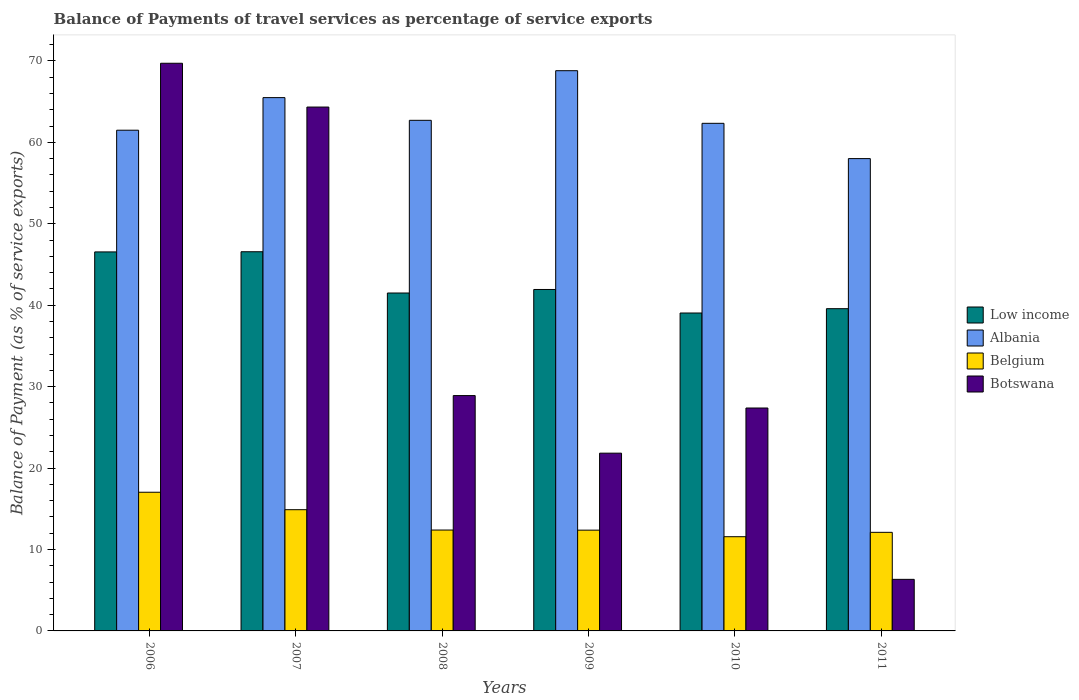Are the number of bars on each tick of the X-axis equal?
Ensure brevity in your answer.  Yes. What is the label of the 4th group of bars from the left?
Give a very brief answer. 2009. In how many cases, is the number of bars for a given year not equal to the number of legend labels?
Keep it short and to the point. 0. What is the balance of payments of travel services in Albania in 2006?
Ensure brevity in your answer.  61.49. Across all years, what is the maximum balance of payments of travel services in Botswana?
Provide a succinct answer. 69.71. Across all years, what is the minimum balance of payments of travel services in Low income?
Offer a very short reply. 39.04. In which year was the balance of payments of travel services in Low income maximum?
Ensure brevity in your answer.  2007. What is the total balance of payments of travel services in Low income in the graph?
Your answer should be very brief. 255.15. What is the difference between the balance of payments of travel services in Low income in 2009 and that in 2010?
Give a very brief answer. 2.89. What is the difference between the balance of payments of travel services in Botswana in 2007 and the balance of payments of travel services in Low income in 2009?
Provide a succinct answer. 22.4. What is the average balance of payments of travel services in Albania per year?
Your answer should be very brief. 63.14. In the year 2008, what is the difference between the balance of payments of travel services in Low income and balance of payments of travel services in Botswana?
Provide a succinct answer. 12.6. In how many years, is the balance of payments of travel services in Belgium greater than 18 %?
Your answer should be compact. 0. What is the ratio of the balance of payments of travel services in Low income in 2008 to that in 2009?
Make the answer very short. 0.99. Is the balance of payments of travel services in Belgium in 2008 less than that in 2010?
Offer a terse response. No. What is the difference between the highest and the second highest balance of payments of travel services in Albania?
Offer a terse response. 3.31. What is the difference between the highest and the lowest balance of payments of travel services in Belgium?
Provide a short and direct response. 5.46. What does the 4th bar from the left in 2007 represents?
Ensure brevity in your answer.  Botswana. What does the 1st bar from the right in 2010 represents?
Offer a terse response. Botswana. Is it the case that in every year, the sum of the balance of payments of travel services in Belgium and balance of payments of travel services in Albania is greater than the balance of payments of travel services in Low income?
Keep it short and to the point. Yes. How many bars are there?
Your response must be concise. 24. What is the difference between two consecutive major ticks on the Y-axis?
Provide a short and direct response. 10. Where does the legend appear in the graph?
Offer a terse response. Center right. How many legend labels are there?
Offer a very short reply. 4. What is the title of the graph?
Give a very brief answer. Balance of Payments of travel services as percentage of service exports. Does "Japan" appear as one of the legend labels in the graph?
Offer a terse response. No. What is the label or title of the Y-axis?
Your answer should be very brief. Balance of Payment (as % of service exports). What is the Balance of Payment (as % of service exports) in Low income in 2006?
Offer a terse response. 46.54. What is the Balance of Payment (as % of service exports) of Albania in 2006?
Provide a short and direct response. 61.49. What is the Balance of Payment (as % of service exports) of Belgium in 2006?
Your response must be concise. 17.03. What is the Balance of Payment (as % of service exports) of Botswana in 2006?
Provide a short and direct response. 69.71. What is the Balance of Payment (as % of service exports) in Low income in 2007?
Give a very brief answer. 46.56. What is the Balance of Payment (as % of service exports) of Albania in 2007?
Provide a succinct answer. 65.49. What is the Balance of Payment (as % of service exports) of Belgium in 2007?
Your response must be concise. 14.89. What is the Balance of Payment (as % of service exports) of Botswana in 2007?
Give a very brief answer. 64.33. What is the Balance of Payment (as % of service exports) of Low income in 2008?
Make the answer very short. 41.5. What is the Balance of Payment (as % of service exports) in Albania in 2008?
Your answer should be compact. 62.7. What is the Balance of Payment (as % of service exports) of Belgium in 2008?
Your answer should be compact. 12.39. What is the Balance of Payment (as % of service exports) in Botswana in 2008?
Offer a very short reply. 28.9. What is the Balance of Payment (as % of service exports) in Low income in 2009?
Give a very brief answer. 41.93. What is the Balance of Payment (as % of service exports) of Albania in 2009?
Offer a terse response. 68.8. What is the Balance of Payment (as % of service exports) of Belgium in 2009?
Ensure brevity in your answer.  12.37. What is the Balance of Payment (as % of service exports) of Botswana in 2009?
Provide a succinct answer. 21.83. What is the Balance of Payment (as % of service exports) in Low income in 2010?
Keep it short and to the point. 39.04. What is the Balance of Payment (as % of service exports) in Albania in 2010?
Your response must be concise. 62.34. What is the Balance of Payment (as % of service exports) in Belgium in 2010?
Your answer should be very brief. 11.57. What is the Balance of Payment (as % of service exports) in Botswana in 2010?
Keep it short and to the point. 27.38. What is the Balance of Payment (as % of service exports) in Low income in 2011?
Ensure brevity in your answer.  39.57. What is the Balance of Payment (as % of service exports) of Albania in 2011?
Make the answer very short. 58. What is the Balance of Payment (as % of service exports) of Belgium in 2011?
Your answer should be very brief. 12.11. What is the Balance of Payment (as % of service exports) in Botswana in 2011?
Your response must be concise. 6.33. Across all years, what is the maximum Balance of Payment (as % of service exports) in Low income?
Ensure brevity in your answer.  46.56. Across all years, what is the maximum Balance of Payment (as % of service exports) of Albania?
Your response must be concise. 68.8. Across all years, what is the maximum Balance of Payment (as % of service exports) in Belgium?
Your response must be concise. 17.03. Across all years, what is the maximum Balance of Payment (as % of service exports) in Botswana?
Provide a short and direct response. 69.71. Across all years, what is the minimum Balance of Payment (as % of service exports) of Low income?
Your response must be concise. 39.04. Across all years, what is the minimum Balance of Payment (as % of service exports) of Albania?
Your response must be concise. 58. Across all years, what is the minimum Balance of Payment (as % of service exports) of Belgium?
Provide a succinct answer. 11.57. Across all years, what is the minimum Balance of Payment (as % of service exports) in Botswana?
Provide a short and direct response. 6.33. What is the total Balance of Payment (as % of service exports) in Low income in the graph?
Give a very brief answer. 255.15. What is the total Balance of Payment (as % of service exports) of Albania in the graph?
Offer a terse response. 378.83. What is the total Balance of Payment (as % of service exports) in Belgium in the graph?
Ensure brevity in your answer.  80.36. What is the total Balance of Payment (as % of service exports) in Botswana in the graph?
Ensure brevity in your answer.  218.49. What is the difference between the Balance of Payment (as % of service exports) of Low income in 2006 and that in 2007?
Offer a very short reply. -0.02. What is the difference between the Balance of Payment (as % of service exports) of Albania in 2006 and that in 2007?
Your answer should be compact. -4. What is the difference between the Balance of Payment (as % of service exports) of Belgium in 2006 and that in 2007?
Your answer should be very brief. 2.14. What is the difference between the Balance of Payment (as % of service exports) of Botswana in 2006 and that in 2007?
Your response must be concise. 5.38. What is the difference between the Balance of Payment (as % of service exports) of Low income in 2006 and that in 2008?
Provide a short and direct response. 5.05. What is the difference between the Balance of Payment (as % of service exports) in Albania in 2006 and that in 2008?
Provide a succinct answer. -1.21. What is the difference between the Balance of Payment (as % of service exports) of Belgium in 2006 and that in 2008?
Provide a short and direct response. 4.64. What is the difference between the Balance of Payment (as % of service exports) of Botswana in 2006 and that in 2008?
Provide a succinct answer. 40.81. What is the difference between the Balance of Payment (as % of service exports) of Low income in 2006 and that in 2009?
Offer a very short reply. 4.61. What is the difference between the Balance of Payment (as % of service exports) of Albania in 2006 and that in 2009?
Offer a very short reply. -7.31. What is the difference between the Balance of Payment (as % of service exports) in Belgium in 2006 and that in 2009?
Offer a very short reply. 4.66. What is the difference between the Balance of Payment (as % of service exports) of Botswana in 2006 and that in 2009?
Your answer should be compact. 47.88. What is the difference between the Balance of Payment (as % of service exports) in Low income in 2006 and that in 2010?
Give a very brief answer. 7.5. What is the difference between the Balance of Payment (as % of service exports) of Albania in 2006 and that in 2010?
Keep it short and to the point. -0.85. What is the difference between the Balance of Payment (as % of service exports) of Belgium in 2006 and that in 2010?
Keep it short and to the point. 5.46. What is the difference between the Balance of Payment (as % of service exports) of Botswana in 2006 and that in 2010?
Your answer should be very brief. 42.34. What is the difference between the Balance of Payment (as % of service exports) in Low income in 2006 and that in 2011?
Offer a very short reply. 6.97. What is the difference between the Balance of Payment (as % of service exports) in Albania in 2006 and that in 2011?
Keep it short and to the point. 3.49. What is the difference between the Balance of Payment (as % of service exports) in Belgium in 2006 and that in 2011?
Provide a short and direct response. 4.92. What is the difference between the Balance of Payment (as % of service exports) of Botswana in 2006 and that in 2011?
Ensure brevity in your answer.  63.38. What is the difference between the Balance of Payment (as % of service exports) in Low income in 2007 and that in 2008?
Your response must be concise. 5.07. What is the difference between the Balance of Payment (as % of service exports) in Albania in 2007 and that in 2008?
Make the answer very short. 2.79. What is the difference between the Balance of Payment (as % of service exports) in Belgium in 2007 and that in 2008?
Offer a very short reply. 2.5. What is the difference between the Balance of Payment (as % of service exports) of Botswana in 2007 and that in 2008?
Provide a short and direct response. 35.43. What is the difference between the Balance of Payment (as % of service exports) in Low income in 2007 and that in 2009?
Offer a very short reply. 4.63. What is the difference between the Balance of Payment (as % of service exports) in Albania in 2007 and that in 2009?
Offer a very short reply. -3.31. What is the difference between the Balance of Payment (as % of service exports) in Belgium in 2007 and that in 2009?
Provide a short and direct response. 2.51. What is the difference between the Balance of Payment (as % of service exports) of Botswana in 2007 and that in 2009?
Your answer should be compact. 42.5. What is the difference between the Balance of Payment (as % of service exports) of Low income in 2007 and that in 2010?
Your answer should be compact. 7.52. What is the difference between the Balance of Payment (as % of service exports) of Albania in 2007 and that in 2010?
Keep it short and to the point. 3.16. What is the difference between the Balance of Payment (as % of service exports) of Belgium in 2007 and that in 2010?
Ensure brevity in your answer.  3.32. What is the difference between the Balance of Payment (as % of service exports) of Botswana in 2007 and that in 2010?
Your response must be concise. 36.96. What is the difference between the Balance of Payment (as % of service exports) of Low income in 2007 and that in 2011?
Keep it short and to the point. 6.99. What is the difference between the Balance of Payment (as % of service exports) in Albania in 2007 and that in 2011?
Your answer should be very brief. 7.49. What is the difference between the Balance of Payment (as % of service exports) in Belgium in 2007 and that in 2011?
Ensure brevity in your answer.  2.78. What is the difference between the Balance of Payment (as % of service exports) in Botswana in 2007 and that in 2011?
Give a very brief answer. 58. What is the difference between the Balance of Payment (as % of service exports) in Low income in 2008 and that in 2009?
Make the answer very short. -0.43. What is the difference between the Balance of Payment (as % of service exports) of Albania in 2008 and that in 2009?
Keep it short and to the point. -6.09. What is the difference between the Balance of Payment (as % of service exports) of Belgium in 2008 and that in 2009?
Provide a succinct answer. 0.01. What is the difference between the Balance of Payment (as % of service exports) in Botswana in 2008 and that in 2009?
Offer a very short reply. 7.07. What is the difference between the Balance of Payment (as % of service exports) in Low income in 2008 and that in 2010?
Keep it short and to the point. 2.46. What is the difference between the Balance of Payment (as % of service exports) in Albania in 2008 and that in 2010?
Keep it short and to the point. 0.37. What is the difference between the Balance of Payment (as % of service exports) of Belgium in 2008 and that in 2010?
Ensure brevity in your answer.  0.82. What is the difference between the Balance of Payment (as % of service exports) in Botswana in 2008 and that in 2010?
Give a very brief answer. 1.53. What is the difference between the Balance of Payment (as % of service exports) in Low income in 2008 and that in 2011?
Provide a short and direct response. 1.92. What is the difference between the Balance of Payment (as % of service exports) in Albania in 2008 and that in 2011?
Offer a terse response. 4.7. What is the difference between the Balance of Payment (as % of service exports) of Belgium in 2008 and that in 2011?
Offer a very short reply. 0.28. What is the difference between the Balance of Payment (as % of service exports) of Botswana in 2008 and that in 2011?
Your answer should be very brief. 22.57. What is the difference between the Balance of Payment (as % of service exports) of Low income in 2009 and that in 2010?
Provide a succinct answer. 2.89. What is the difference between the Balance of Payment (as % of service exports) of Albania in 2009 and that in 2010?
Offer a terse response. 6.46. What is the difference between the Balance of Payment (as % of service exports) of Belgium in 2009 and that in 2010?
Offer a very short reply. 0.81. What is the difference between the Balance of Payment (as % of service exports) in Botswana in 2009 and that in 2010?
Your answer should be very brief. -5.55. What is the difference between the Balance of Payment (as % of service exports) in Low income in 2009 and that in 2011?
Your answer should be very brief. 2.36. What is the difference between the Balance of Payment (as % of service exports) of Albania in 2009 and that in 2011?
Your answer should be compact. 10.79. What is the difference between the Balance of Payment (as % of service exports) of Belgium in 2009 and that in 2011?
Give a very brief answer. 0.27. What is the difference between the Balance of Payment (as % of service exports) in Botswana in 2009 and that in 2011?
Your answer should be compact. 15.5. What is the difference between the Balance of Payment (as % of service exports) of Low income in 2010 and that in 2011?
Provide a short and direct response. -0.53. What is the difference between the Balance of Payment (as % of service exports) in Albania in 2010 and that in 2011?
Provide a short and direct response. 4.33. What is the difference between the Balance of Payment (as % of service exports) of Belgium in 2010 and that in 2011?
Offer a very short reply. -0.54. What is the difference between the Balance of Payment (as % of service exports) of Botswana in 2010 and that in 2011?
Make the answer very short. 21.04. What is the difference between the Balance of Payment (as % of service exports) in Low income in 2006 and the Balance of Payment (as % of service exports) in Albania in 2007?
Your answer should be compact. -18.95. What is the difference between the Balance of Payment (as % of service exports) of Low income in 2006 and the Balance of Payment (as % of service exports) of Belgium in 2007?
Offer a terse response. 31.66. What is the difference between the Balance of Payment (as % of service exports) in Low income in 2006 and the Balance of Payment (as % of service exports) in Botswana in 2007?
Give a very brief answer. -17.79. What is the difference between the Balance of Payment (as % of service exports) in Albania in 2006 and the Balance of Payment (as % of service exports) in Belgium in 2007?
Make the answer very short. 46.6. What is the difference between the Balance of Payment (as % of service exports) in Albania in 2006 and the Balance of Payment (as % of service exports) in Botswana in 2007?
Keep it short and to the point. -2.84. What is the difference between the Balance of Payment (as % of service exports) of Belgium in 2006 and the Balance of Payment (as % of service exports) of Botswana in 2007?
Your response must be concise. -47.3. What is the difference between the Balance of Payment (as % of service exports) of Low income in 2006 and the Balance of Payment (as % of service exports) of Albania in 2008?
Your answer should be very brief. -16.16. What is the difference between the Balance of Payment (as % of service exports) in Low income in 2006 and the Balance of Payment (as % of service exports) in Belgium in 2008?
Your response must be concise. 34.16. What is the difference between the Balance of Payment (as % of service exports) in Low income in 2006 and the Balance of Payment (as % of service exports) in Botswana in 2008?
Offer a terse response. 17.64. What is the difference between the Balance of Payment (as % of service exports) in Albania in 2006 and the Balance of Payment (as % of service exports) in Belgium in 2008?
Ensure brevity in your answer.  49.1. What is the difference between the Balance of Payment (as % of service exports) in Albania in 2006 and the Balance of Payment (as % of service exports) in Botswana in 2008?
Your answer should be very brief. 32.59. What is the difference between the Balance of Payment (as % of service exports) in Belgium in 2006 and the Balance of Payment (as % of service exports) in Botswana in 2008?
Offer a terse response. -11.87. What is the difference between the Balance of Payment (as % of service exports) in Low income in 2006 and the Balance of Payment (as % of service exports) in Albania in 2009?
Offer a terse response. -22.25. What is the difference between the Balance of Payment (as % of service exports) in Low income in 2006 and the Balance of Payment (as % of service exports) in Belgium in 2009?
Provide a succinct answer. 34.17. What is the difference between the Balance of Payment (as % of service exports) of Low income in 2006 and the Balance of Payment (as % of service exports) of Botswana in 2009?
Ensure brevity in your answer.  24.72. What is the difference between the Balance of Payment (as % of service exports) in Albania in 2006 and the Balance of Payment (as % of service exports) in Belgium in 2009?
Ensure brevity in your answer.  49.12. What is the difference between the Balance of Payment (as % of service exports) in Albania in 2006 and the Balance of Payment (as % of service exports) in Botswana in 2009?
Keep it short and to the point. 39.66. What is the difference between the Balance of Payment (as % of service exports) in Belgium in 2006 and the Balance of Payment (as % of service exports) in Botswana in 2009?
Provide a succinct answer. -4.8. What is the difference between the Balance of Payment (as % of service exports) of Low income in 2006 and the Balance of Payment (as % of service exports) of Albania in 2010?
Your answer should be very brief. -15.79. What is the difference between the Balance of Payment (as % of service exports) of Low income in 2006 and the Balance of Payment (as % of service exports) of Belgium in 2010?
Ensure brevity in your answer.  34.98. What is the difference between the Balance of Payment (as % of service exports) of Low income in 2006 and the Balance of Payment (as % of service exports) of Botswana in 2010?
Provide a succinct answer. 19.17. What is the difference between the Balance of Payment (as % of service exports) of Albania in 2006 and the Balance of Payment (as % of service exports) of Belgium in 2010?
Your answer should be compact. 49.92. What is the difference between the Balance of Payment (as % of service exports) in Albania in 2006 and the Balance of Payment (as % of service exports) in Botswana in 2010?
Offer a terse response. 34.12. What is the difference between the Balance of Payment (as % of service exports) in Belgium in 2006 and the Balance of Payment (as % of service exports) in Botswana in 2010?
Keep it short and to the point. -10.34. What is the difference between the Balance of Payment (as % of service exports) in Low income in 2006 and the Balance of Payment (as % of service exports) in Albania in 2011?
Offer a terse response. -11.46. What is the difference between the Balance of Payment (as % of service exports) in Low income in 2006 and the Balance of Payment (as % of service exports) in Belgium in 2011?
Give a very brief answer. 34.44. What is the difference between the Balance of Payment (as % of service exports) of Low income in 2006 and the Balance of Payment (as % of service exports) of Botswana in 2011?
Your answer should be very brief. 40.21. What is the difference between the Balance of Payment (as % of service exports) in Albania in 2006 and the Balance of Payment (as % of service exports) in Belgium in 2011?
Ensure brevity in your answer.  49.38. What is the difference between the Balance of Payment (as % of service exports) in Albania in 2006 and the Balance of Payment (as % of service exports) in Botswana in 2011?
Keep it short and to the point. 55.16. What is the difference between the Balance of Payment (as % of service exports) in Belgium in 2006 and the Balance of Payment (as % of service exports) in Botswana in 2011?
Offer a very short reply. 10.7. What is the difference between the Balance of Payment (as % of service exports) in Low income in 2007 and the Balance of Payment (as % of service exports) in Albania in 2008?
Offer a terse response. -16.14. What is the difference between the Balance of Payment (as % of service exports) in Low income in 2007 and the Balance of Payment (as % of service exports) in Belgium in 2008?
Offer a terse response. 34.18. What is the difference between the Balance of Payment (as % of service exports) in Low income in 2007 and the Balance of Payment (as % of service exports) in Botswana in 2008?
Your response must be concise. 17.66. What is the difference between the Balance of Payment (as % of service exports) in Albania in 2007 and the Balance of Payment (as % of service exports) in Belgium in 2008?
Offer a very short reply. 53.1. What is the difference between the Balance of Payment (as % of service exports) in Albania in 2007 and the Balance of Payment (as % of service exports) in Botswana in 2008?
Make the answer very short. 36.59. What is the difference between the Balance of Payment (as % of service exports) in Belgium in 2007 and the Balance of Payment (as % of service exports) in Botswana in 2008?
Offer a terse response. -14.01. What is the difference between the Balance of Payment (as % of service exports) of Low income in 2007 and the Balance of Payment (as % of service exports) of Albania in 2009?
Your response must be concise. -22.23. What is the difference between the Balance of Payment (as % of service exports) in Low income in 2007 and the Balance of Payment (as % of service exports) in Belgium in 2009?
Give a very brief answer. 34.19. What is the difference between the Balance of Payment (as % of service exports) in Low income in 2007 and the Balance of Payment (as % of service exports) in Botswana in 2009?
Make the answer very short. 24.74. What is the difference between the Balance of Payment (as % of service exports) in Albania in 2007 and the Balance of Payment (as % of service exports) in Belgium in 2009?
Make the answer very short. 53.12. What is the difference between the Balance of Payment (as % of service exports) in Albania in 2007 and the Balance of Payment (as % of service exports) in Botswana in 2009?
Ensure brevity in your answer.  43.66. What is the difference between the Balance of Payment (as % of service exports) of Belgium in 2007 and the Balance of Payment (as % of service exports) of Botswana in 2009?
Provide a short and direct response. -6.94. What is the difference between the Balance of Payment (as % of service exports) in Low income in 2007 and the Balance of Payment (as % of service exports) in Albania in 2010?
Make the answer very short. -15.77. What is the difference between the Balance of Payment (as % of service exports) of Low income in 2007 and the Balance of Payment (as % of service exports) of Belgium in 2010?
Ensure brevity in your answer.  35. What is the difference between the Balance of Payment (as % of service exports) of Low income in 2007 and the Balance of Payment (as % of service exports) of Botswana in 2010?
Your response must be concise. 19.19. What is the difference between the Balance of Payment (as % of service exports) in Albania in 2007 and the Balance of Payment (as % of service exports) in Belgium in 2010?
Keep it short and to the point. 53.92. What is the difference between the Balance of Payment (as % of service exports) in Albania in 2007 and the Balance of Payment (as % of service exports) in Botswana in 2010?
Make the answer very short. 38.12. What is the difference between the Balance of Payment (as % of service exports) of Belgium in 2007 and the Balance of Payment (as % of service exports) of Botswana in 2010?
Your response must be concise. -12.49. What is the difference between the Balance of Payment (as % of service exports) in Low income in 2007 and the Balance of Payment (as % of service exports) in Albania in 2011?
Ensure brevity in your answer.  -11.44. What is the difference between the Balance of Payment (as % of service exports) of Low income in 2007 and the Balance of Payment (as % of service exports) of Belgium in 2011?
Offer a terse response. 34.46. What is the difference between the Balance of Payment (as % of service exports) in Low income in 2007 and the Balance of Payment (as % of service exports) in Botswana in 2011?
Offer a very short reply. 40.23. What is the difference between the Balance of Payment (as % of service exports) in Albania in 2007 and the Balance of Payment (as % of service exports) in Belgium in 2011?
Offer a very short reply. 53.39. What is the difference between the Balance of Payment (as % of service exports) of Albania in 2007 and the Balance of Payment (as % of service exports) of Botswana in 2011?
Keep it short and to the point. 59.16. What is the difference between the Balance of Payment (as % of service exports) in Belgium in 2007 and the Balance of Payment (as % of service exports) in Botswana in 2011?
Offer a terse response. 8.55. What is the difference between the Balance of Payment (as % of service exports) in Low income in 2008 and the Balance of Payment (as % of service exports) in Albania in 2009?
Your answer should be compact. -27.3. What is the difference between the Balance of Payment (as % of service exports) of Low income in 2008 and the Balance of Payment (as % of service exports) of Belgium in 2009?
Keep it short and to the point. 29.12. What is the difference between the Balance of Payment (as % of service exports) in Low income in 2008 and the Balance of Payment (as % of service exports) in Botswana in 2009?
Provide a short and direct response. 19.67. What is the difference between the Balance of Payment (as % of service exports) of Albania in 2008 and the Balance of Payment (as % of service exports) of Belgium in 2009?
Keep it short and to the point. 50.33. What is the difference between the Balance of Payment (as % of service exports) in Albania in 2008 and the Balance of Payment (as % of service exports) in Botswana in 2009?
Offer a very short reply. 40.88. What is the difference between the Balance of Payment (as % of service exports) of Belgium in 2008 and the Balance of Payment (as % of service exports) of Botswana in 2009?
Ensure brevity in your answer.  -9.44. What is the difference between the Balance of Payment (as % of service exports) in Low income in 2008 and the Balance of Payment (as % of service exports) in Albania in 2010?
Provide a succinct answer. -20.84. What is the difference between the Balance of Payment (as % of service exports) of Low income in 2008 and the Balance of Payment (as % of service exports) of Belgium in 2010?
Offer a very short reply. 29.93. What is the difference between the Balance of Payment (as % of service exports) in Low income in 2008 and the Balance of Payment (as % of service exports) in Botswana in 2010?
Provide a succinct answer. 14.12. What is the difference between the Balance of Payment (as % of service exports) in Albania in 2008 and the Balance of Payment (as % of service exports) in Belgium in 2010?
Your answer should be very brief. 51.14. What is the difference between the Balance of Payment (as % of service exports) of Albania in 2008 and the Balance of Payment (as % of service exports) of Botswana in 2010?
Offer a terse response. 35.33. What is the difference between the Balance of Payment (as % of service exports) in Belgium in 2008 and the Balance of Payment (as % of service exports) in Botswana in 2010?
Keep it short and to the point. -14.99. What is the difference between the Balance of Payment (as % of service exports) of Low income in 2008 and the Balance of Payment (as % of service exports) of Albania in 2011?
Give a very brief answer. -16.51. What is the difference between the Balance of Payment (as % of service exports) of Low income in 2008 and the Balance of Payment (as % of service exports) of Belgium in 2011?
Ensure brevity in your answer.  29.39. What is the difference between the Balance of Payment (as % of service exports) in Low income in 2008 and the Balance of Payment (as % of service exports) in Botswana in 2011?
Keep it short and to the point. 35.16. What is the difference between the Balance of Payment (as % of service exports) of Albania in 2008 and the Balance of Payment (as % of service exports) of Belgium in 2011?
Give a very brief answer. 50.6. What is the difference between the Balance of Payment (as % of service exports) in Albania in 2008 and the Balance of Payment (as % of service exports) in Botswana in 2011?
Give a very brief answer. 56.37. What is the difference between the Balance of Payment (as % of service exports) of Belgium in 2008 and the Balance of Payment (as % of service exports) of Botswana in 2011?
Ensure brevity in your answer.  6.06. What is the difference between the Balance of Payment (as % of service exports) in Low income in 2009 and the Balance of Payment (as % of service exports) in Albania in 2010?
Provide a short and direct response. -20.41. What is the difference between the Balance of Payment (as % of service exports) in Low income in 2009 and the Balance of Payment (as % of service exports) in Belgium in 2010?
Make the answer very short. 30.36. What is the difference between the Balance of Payment (as % of service exports) of Low income in 2009 and the Balance of Payment (as % of service exports) of Botswana in 2010?
Ensure brevity in your answer.  14.56. What is the difference between the Balance of Payment (as % of service exports) of Albania in 2009 and the Balance of Payment (as % of service exports) of Belgium in 2010?
Give a very brief answer. 57.23. What is the difference between the Balance of Payment (as % of service exports) in Albania in 2009 and the Balance of Payment (as % of service exports) in Botswana in 2010?
Give a very brief answer. 41.42. What is the difference between the Balance of Payment (as % of service exports) of Belgium in 2009 and the Balance of Payment (as % of service exports) of Botswana in 2010?
Provide a short and direct response. -15. What is the difference between the Balance of Payment (as % of service exports) of Low income in 2009 and the Balance of Payment (as % of service exports) of Albania in 2011?
Make the answer very short. -16.07. What is the difference between the Balance of Payment (as % of service exports) of Low income in 2009 and the Balance of Payment (as % of service exports) of Belgium in 2011?
Offer a very short reply. 29.82. What is the difference between the Balance of Payment (as % of service exports) in Low income in 2009 and the Balance of Payment (as % of service exports) in Botswana in 2011?
Your response must be concise. 35.6. What is the difference between the Balance of Payment (as % of service exports) of Albania in 2009 and the Balance of Payment (as % of service exports) of Belgium in 2011?
Make the answer very short. 56.69. What is the difference between the Balance of Payment (as % of service exports) of Albania in 2009 and the Balance of Payment (as % of service exports) of Botswana in 2011?
Ensure brevity in your answer.  62.46. What is the difference between the Balance of Payment (as % of service exports) in Belgium in 2009 and the Balance of Payment (as % of service exports) in Botswana in 2011?
Your response must be concise. 6.04. What is the difference between the Balance of Payment (as % of service exports) of Low income in 2010 and the Balance of Payment (as % of service exports) of Albania in 2011?
Ensure brevity in your answer.  -18.96. What is the difference between the Balance of Payment (as % of service exports) of Low income in 2010 and the Balance of Payment (as % of service exports) of Belgium in 2011?
Give a very brief answer. 26.93. What is the difference between the Balance of Payment (as % of service exports) of Low income in 2010 and the Balance of Payment (as % of service exports) of Botswana in 2011?
Provide a short and direct response. 32.71. What is the difference between the Balance of Payment (as % of service exports) in Albania in 2010 and the Balance of Payment (as % of service exports) in Belgium in 2011?
Your answer should be very brief. 50.23. What is the difference between the Balance of Payment (as % of service exports) in Albania in 2010 and the Balance of Payment (as % of service exports) in Botswana in 2011?
Provide a short and direct response. 56. What is the difference between the Balance of Payment (as % of service exports) of Belgium in 2010 and the Balance of Payment (as % of service exports) of Botswana in 2011?
Your answer should be very brief. 5.24. What is the average Balance of Payment (as % of service exports) in Low income per year?
Your answer should be compact. 42.53. What is the average Balance of Payment (as % of service exports) in Albania per year?
Ensure brevity in your answer.  63.14. What is the average Balance of Payment (as % of service exports) of Belgium per year?
Give a very brief answer. 13.39. What is the average Balance of Payment (as % of service exports) in Botswana per year?
Provide a short and direct response. 36.41. In the year 2006, what is the difference between the Balance of Payment (as % of service exports) of Low income and Balance of Payment (as % of service exports) of Albania?
Your answer should be compact. -14.95. In the year 2006, what is the difference between the Balance of Payment (as % of service exports) of Low income and Balance of Payment (as % of service exports) of Belgium?
Provide a short and direct response. 29.51. In the year 2006, what is the difference between the Balance of Payment (as % of service exports) of Low income and Balance of Payment (as % of service exports) of Botswana?
Make the answer very short. -23.17. In the year 2006, what is the difference between the Balance of Payment (as % of service exports) in Albania and Balance of Payment (as % of service exports) in Belgium?
Provide a succinct answer. 44.46. In the year 2006, what is the difference between the Balance of Payment (as % of service exports) in Albania and Balance of Payment (as % of service exports) in Botswana?
Offer a terse response. -8.22. In the year 2006, what is the difference between the Balance of Payment (as % of service exports) of Belgium and Balance of Payment (as % of service exports) of Botswana?
Your answer should be very brief. -52.68. In the year 2007, what is the difference between the Balance of Payment (as % of service exports) of Low income and Balance of Payment (as % of service exports) of Albania?
Provide a short and direct response. -18.93. In the year 2007, what is the difference between the Balance of Payment (as % of service exports) in Low income and Balance of Payment (as % of service exports) in Belgium?
Ensure brevity in your answer.  31.68. In the year 2007, what is the difference between the Balance of Payment (as % of service exports) in Low income and Balance of Payment (as % of service exports) in Botswana?
Make the answer very short. -17.77. In the year 2007, what is the difference between the Balance of Payment (as % of service exports) of Albania and Balance of Payment (as % of service exports) of Belgium?
Make the answer very short. 50.6. In the year 2007, what is the difference between the Balance of Payment (as % of service exports) in Albania and Balance of Payment (as % of service exports) in Botswana?
Give a very brief answer. 1.16. In the year 2007, what is the difference between the Balance of Payment (as % of service exports) of Belgium and Balance of Payment (as % of service exports) of Botswana?
Keep it short and to the point. -49.45. In the year 2008, what is the difference between the Balance of Payment (as % of service exports) of Low income and Balance of Payment (as % of service exports) of Albania?
Make the answer very short. -21.21. In the year 2008, what is the difference between the Balance of Payment (as % of service exports) in Low income and Balance of Payment (as % of service exports) in Belgium?
Give a very brief answer. 29.11. In the year 2008, what is the difference between the Balance of Payment (as % of service exports) of Low income and Balance of Payment (as % of service exports) of Botswana?
Make the answer very short. 12.6. In the year 2008, what is the difference between the Balance of Payment (as % of service exports) of Albania and Balance of Payment (as % of service exports) of Belgium?
Your answer should be compact. 50.32. In the year 2008, what is the difference between the Balance of Payment (as % of service exports) in Albania and Balance of Payment (as % of service exports) in Botswana?
Provide a succinct answer. 33.8. In the year 2008, what is the difference between the Balance of Payment (as % of service exports) in Belgium and Balance of Payment (as % of service exports) in Botswana?
Your response must be concise. -16.51. In the year 2009, what is the difference between the Balance of Payment (as % of service exports) of Low income and Balance of Payment (as % of service exports) of Albania?
Ensure brevity in your answer.  -26.87. In the year 2009, what is the difference between the Balance of Payment (as % of service exports) of Low income and Balance of Payment (as % of service exports) of Belgium?
Provide a short and direct response. 29.56. In the year 2009, what is the difference between the Balance of Payment (as % of service exports) of Low income and Balance of Payment (as % of service exports) of Botswana?
Give a very brief answer. 20.1. In the year 2009, what is the difference between the Balance of Payment (as % of service exports) in Albania and Balance of Payment (as % of service exports) in Belgium?
Make the answer very short. 56.42. In the year 2009, what is the difference between the Balance of Payment (as % of service exports) of Albania and Balance of Payment (as % of service exports) of Botswana?
Make the answer very short. 46.97. In the year 2009, what is the difference between the Balance of Payment (as % of service exports) in Belgium and Balance of Payment (as % of service exports) in Botswana?
Your answer should be very brief. -9.45. In the year 2010, what is the difference between the Balance of Payment (as % of service exports) in Low income and Balance of Payment (as % of service exports) in Albania?
Your answer should be very brief. -23.3. In the year 2010, what is the difference between the Balance of Payment (as % of service exports) in Low income and Balance of Payment (as % of service exports) in Belgium?
Provide a succinct answer. 27.47. In the year 2010, what is the difference between the Balance of Payment (as % of service exports) in Low income and Balance of Payment (as % of service exports) in Botswana?
Make the answer very short. 11.67. In the year 2010, what is the difference between the Balance of Payment (as % of service exports) in Albania and Balance of Payment (as % of service exports) in Belgium?
Provide a short and direct response. 50.77. In the year 2010, what is the difference between the Balance of Payment (as % of service exports) of Albania and Balance of Payment (as % of service exports) of Botswana?
Provide a short and direct response. 34.96. In the year 2010, what is the difference between the Balance of Payment (as % of service exports) of Belgium and Balance of Payment (as % of service exports) of Botswana?
Provide a short and direct response. -15.81. In the year 2011, what is the difference between the Balance of Payment (as % of service exports) in Low income and Balance of Payment (as % of service exports) in Albania?
Provide a short and direct response. -18.43. In the year 2011, what is the difference between the Balance of Payment (as % of service exports) in Low income and Balance of Payment (as % of service exports) in Belgium?
Your response must be concise. 27.47. In the year 2011, what is the difference between the Balance of Payment (as % of service exports) of Low income and Balance of Payment (as % of service exports) of Botswana?
Your answer should be very brief. 33.24. In the year 2011, what is the difference between the Balance of Payment (as % of service exports) of Albania and Balance of Payment (as % of service exports) of Belgium?
Make the answer very short. 45.9. In the year 2011, what is the difference between the Balance of Payment (as % of service exports) of Albania and Balance of Payment (as % of service exports) of Botswana?
Your answer should be compact. 51.67. In the year 2011, what is the difference between the Balance of Payment (as % of service exports) in Belgium and Balance of Payment (as % of service exports) in Botswana?
Your answer should be compact. 5.77. What is the ratio of the Balance of Payment (as % of service exports) of Low income in 2006 to that in 2007?
Make the answer very short. 1. What is the ratio of the Balance of Payment (as % of service exports) in Albania in 2006 to that in 2007?
Your answer should be very brief. 0.94. What is the ratio of the Balance of Payment (as % of service exports) in Belgium in 2006 to that in 2007?
Your response must be concise. 1.14. What is the ratio of the Balance of Payment (as % of service exports) of Botswana in 2006 to that in 2007?
Offer a terse response. 1.08. What is the ratio of the Balance of Payment (as % of service exports) of Low income in 2006 to that in 2008?
Give a very brief answer. 1.12. What is the ratio of the Balance of Payment (as % of service exports) in Albania in 2006 to that in 2008?
Offer a very short reply. 0.98. What is the ratio of the Balance of Payment (as % of service exports) of Belgium in 2006 to that in 2008?
Provide a succinct answer. 1.37. What is the ratio of the Balance of Payment (as % of service exports) of Botswana in 2006 to that in 2008?
Your answer should be compact. 2.41. What is the ratio of the Balance of Payment (as % of service exports) of Low income in 2006 to that in 2009?
Keep it short and to the point. 1.11. What is the ratio of the Balance of Payment (as % of service exports) in Albania in 2006 to that in 2009?
Give a very brief answer. 0.89. What is the ratio of the Balance of Payment (as % of service exports) in Belgium in 2006 to that in 2009?
Your answer should be very brief. 1.38. What is the ratio of the Balance of Payment (as % of service exports) of Botswana in 2006 to that in 2009?
Ensure brevity in your answer.  3.19. What is the ratio of the Balance of Payment (as % of service exports) in Low income in 2006 to that in 2010?
Give a very brief answer. 1.19. What is the ratio of the Balance of Payment (as % of service exports) in Albania in 2006 to that in 2010?
Your answer should be compact. 0.99. What is the ratio of the Balance of Payment (as % of service exports) in Belgium in 2006 to that in 2010?
Make the answer very short. 1.47. What is the ratio of the Balance of Payment (as % of service exports) in Botswana in 2006 to that in 2010?
Make the answer very short. 2.55. What is the ratio of the Balance of Payment (as % of service exports) in Low income in 2006 to that in 2011?
Your answer should be very brief. 1.18. What is the ratio of the Balance of Payment (as % of service exports) in Albania in 2006 to that in 2011?
Provide a short and direct response. 1.06. What is the ratio of the Balance of Payment (as % of service exports) of Belgium in 2006 to that in 2011?
Keep it short and to the point. 1.41. What is the ratio of the Balance of Payment (as % of service exports) of Botswana in 2006 to that in 2011?
Your response must be concise. 11.01. What is the ratio of the Balance of Payment (as % of service exports) in Low income in 2007 to that in 2008?
Your response must be concise. 1.12. What is the ratio of the Balance of Payment (as % of service exports) in Albania in 2007 to that in 2008?
Provide a succinct answer. 1.04. What is the ratio of the Balance of Payment (as % of service exports) of Belgium in 2007 to that in 2008?
Give a very brief answer. 1.2. What is the ratio of the Balance of Payment (as % of service exports) of Botswana in 2007 to that in 2008?
Provide a short and direct response. 2.23. What is the ratio of the Balance of Payment (as % of service exports) in Low income in 2007 to that in 2009?
Give a very brief answer. 1.11. What is the ratio of the Balance of Payment (as % of service exports) of Albania in 2007 to that in 2009?
Your answer should be compact. 0.95. What is the ratio of the Balance of Payment (as % of service exports) of Belgium in 2007 to that in 2009?
Your answer should be compact. 1.2. What is the ratio of the Balance of Payment (as % of service exports) in Botswana in 2007 to that in 2009?
Keep it short and to the point. 2.95. What is the ratio of the Balance of Payment (as % of service exports) in Low income in 2007 to that in 2010?
Make the answer very short. 1.19. What is the ratio of the Balance of Payment (as % of service exports) in Albania in 2007 to that in 2010?
Keep it short and to the point. 1.05. What is the ratio of the Balance of Payment (as % of service exports) in Belgium in 2007 to that in 2010?
Your answer should be very brief. 1.29. What is the ratio of the Balance of Payment (as % of service exports) in Botswana in 2007 to that in 2010?
Your answer should be compact. 2.35. What is the ratio of the Balance of Payment (as % of service exports) in Low income in 2007 to that in 2011?
Ensure brevity in your answer.  1.18. What is the ratio of the Balance of Payment (as % of service exports) in Albania in 2007 to that in 2011?
Offer a terse response. 1.13. What is the ratio of the Balance of Payment (as % of service exports) of Belgium in 2007 to that in 2011?
Provide a short and direct response. 1.23. What is the ratio of the Balance of Payment (as % of service exports) in Botswana in 2007 to that in 2011?
Provide a succinct answer. 10.16. What is the ratio of the Balance of Payment (as % of service exports) of Albania in 2008 to that in 2009?
Offer a terse response. 0.91. What is the ratio of the Balance of Payment (as % of service exports) in Botswana in 2008 to that in 2009?
Your response must be concise. 1.32. What is the ratio of the Balance of Payment (as % of service exports) in Low income in 2008 to that in 2010?
Your response must be concise. 1.06. What is the ratio of the Balance of Payment (as % of service exports) in Albania in 2008 to that in 2010?
Make the answer very short. 1.01. What is the ratio of the Balance of Payment (as % of service exports) of Belgium in 2008 to that in 2010?
Your answer should be compact. 1.07. What is the ratio of the Balance of Payment (as % of service exports) of Botswana in 2008 to that in 2010?
Offer a terse response. 1.06. What is the ratio of the Balance of Payment (as % of service exports) in Low income in 2008 to that in 2011?
Provide a short and direct response. 1.05. What is the ratio of the Balance of Payment (as % of service exports) in Albania in 2008 to that in 2011?
Ensure brevity in your answer.  1.08. What is the ratio of the Balance of Payment (as % of service exports) in Belgium in 2008 to that in 2011?
Ensure brevity in your answer.  1.02. What is the ratio of the Balance of Payment (as % of service exports) in Botswana in 2008 to that in 2011?
Your answer should be very brief. 4.56. What is the ratio of the Balance of Payment (as % of service exports) in Low income in 2009 to that in 2010?
Your answer should be very brief. 1.07. What is the ratio of the Balance of Payment (as % of service exports) of Albania in 2009 to that in 2010?
Your answer should be compact. 1.1. What is the ratio of the Balance of Payment (as % of service exports) of Belgium in 2009 to that in 2010?
Your answer should be compact. 1.07. What is the ratio of the Balance of Payment (as % of service exports) of Botswana in 2009 to that in 2010?
Provide a succinct answer. 0.8. What is the ratio of the Balance of Payment (as % of service exports) of Low income in 2009 to that in 2011?
Your answer should be compact. 1.06. What is the ratio of the Balance of Payment (as % of service exports) of Albania in 2009 to that in 2011?
Make the answer very short. 1.19. What is the ratio of the Balance of Payment (as % of service exports) in Belgium in 2009 to that in 2011?
Offer a terse response. 1.02. What is the ratio of the Balance of Payment (as % of service exports) of Botswana in 2009 to that in 2011?
Your answer should be very brief. 3.45. What is the ratio of the Balance of Payment (as % of service exports) of Low income in 2010 to that in 2011?
Your answer should be very brief. 0.99. What is the ratio of the Balance of Payment (as % of service exports) in Albania in 2010 to that in 2011?
Ensure brevity in your answer.  1.07. What is the ratio of the Balance of Payment (as % of service exports) in Belgium in 2010 to that in 2011?
Offer a very short reply. 0.96. What is the ratio of the Balance of Payment (as % of service exports) of Botswana in 2010 to that in 2011?
Provide a short and direct response. 4.32. What is the difference between the highest and the second highest Balance of Payment (as % of service exports) in Low income?
Your response must be concise. 0.02. What is the difference between the highest and the second highest Balance of Payment (as % of service exports) in Albania?
Ensure brevity in your answer.  3.31. What is the difference between the highest and the second highest Balance of Payment (as % of service exports) of Belgium?
Give a very brief answer. 2.14. What is the difference between the highest and the second highest Balance of Payment (as % of service exports) in Botswana?
Provide a short and direct response. 5.38. What is the difference between the highest and the lowest Balance of Payment (as % of service exports) in Low income?
Provide a short and direct response. 7.52. What is the difference between the highest and the lowest Balance of Payment (as % of service exports) of Albania?
Make the answer very short. 10.79. What is the difference between the highest and the lowest Balance of Payment (as % of service exports) of Belgium?
Provide a succinct answer. 5.46. What is the difference between the highest and the lowest Balance of Payment (as % of service exports) of Botswana?
Offer a very short reply. 63.38. 